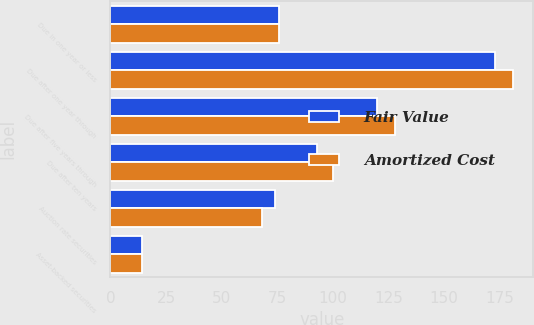Convert chart to OTSL. <chart><loc_0><loc_0><loc_500><loc_500><stacked_bar_chart><ecel><fcel>Due in one year or less<fcel>Due after one year through<fcel>Due after five years through<fcel>Due after ten years<fcel>Auction rate securities<fcel>Asset-backed securities<nl><fcel>Fair Value<fcel>76<fcel>173<fcel>120<fcel>93<fcel>74<fcel>14<nl><fcel>Amortized Cost<fcel>76<fcel>181<fcel>128<fcel>100<fcel>68<fcel>14<nl></chart> 